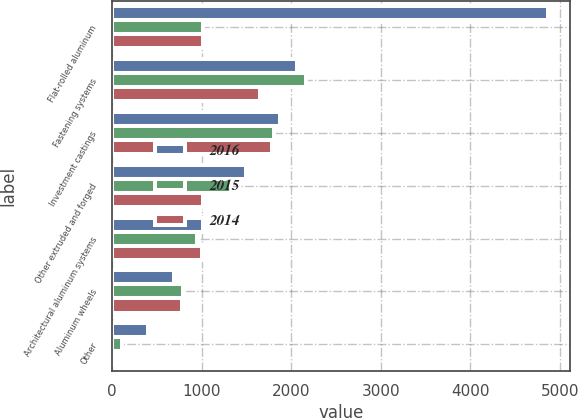<chart> <loc_0><loc_0><loc_500><loc_500><stacked_bar_chart><ecel><fcel>Flat-rolled aluminum<fcel>Fastening systems<fcel>Investment castings<fcel>Other extruded and forged<fcel>Architectural aluminum systems<fcel>Aluminum wheels<fcel>Other<nl><fcel>2016<fcel>4864<fcel>2060<fcel>1870<fcel>1495<fcel>1010<fcel>689<fcel>406<nl><fcel>2015<fcel>1019<fcel>2168<fcel>1812<fcel>1332<fcel>951<fcel>790<fcel>107<nl><fcel>2014<fcel>1019<fcel>1647<fcel>1784<fcel>1019<fcel>1002<fcel>786<fcel>40<nl></chart> 